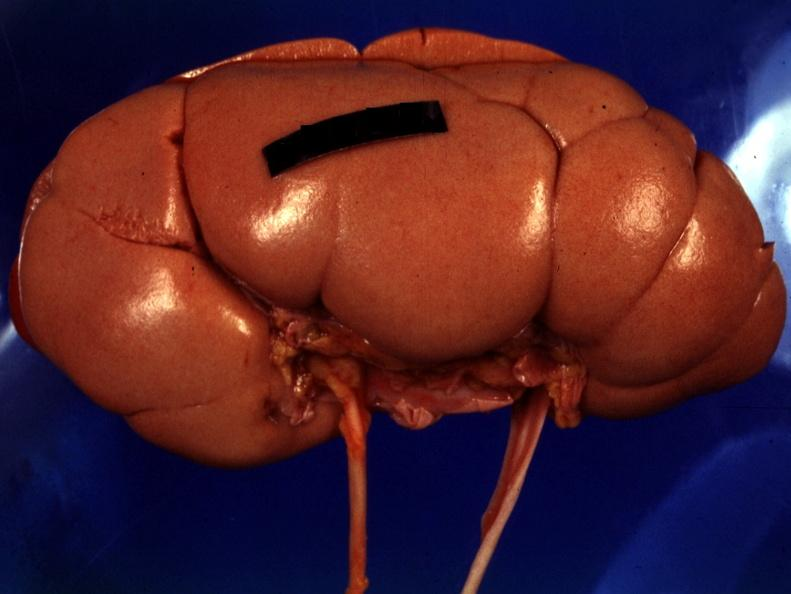what is present?
Answer the question using a single word or phrase. Kidney 